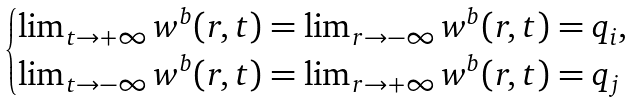Convert formula to latex. <formula><loc_0><loc_0><loc_500><loc_500>\begin{cases} \lim _ { t \to + \infty } w ^ { b } ( r , t ) = \lim _ { r \to - \infty } w ^ { b } ( r , t ) = q _ { i } , \\ \lim _ { t \to - \infty } w ^ { b } ( r , t ) = \lim _ { r \to + \infty } w ^ { b } ( r , t ) = q _ { j } \end{cases}</formula> 